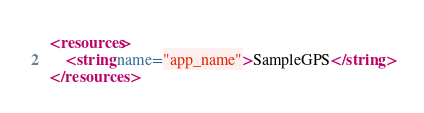Convert code to text. <code><loc_0><loc_0><loc_500><loc_500><_XML_><resources>
    <string name="app_name">SampleGPS</string>
</resources>
</code> 